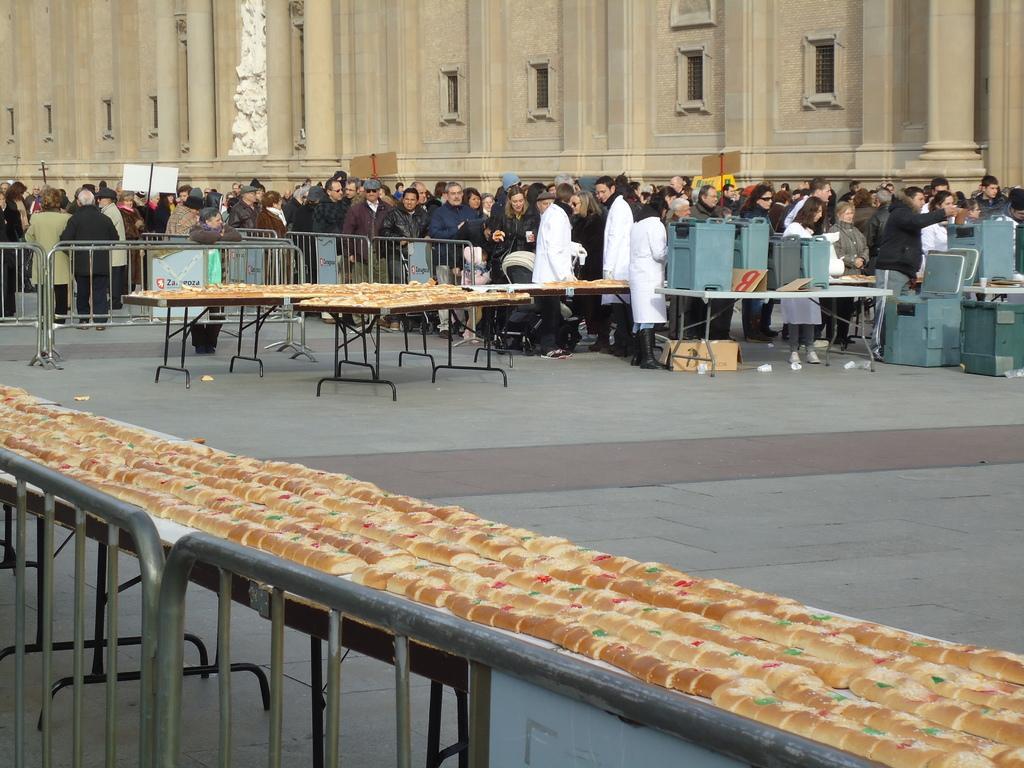Could you give a brief overview of what you see in this image? here we can see a group of people standing on the floor, and at side here is the building, and here are the food items on the table. 